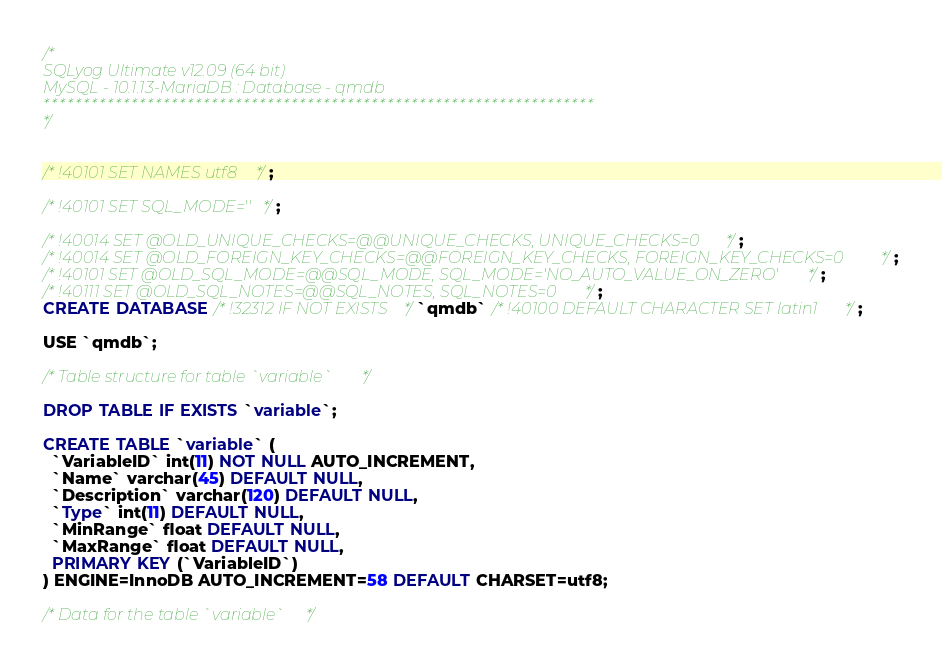Convert code to text. <code><loc_0><loc_0><loc_500><loc_500><_SQL_>/*
SQLyog Ultimate v12.09 (64 bit)
MySQL - 10.1.13-MariaDB : Database - qmdb
*********************************************************************
*/

/*!40101 SET NAMES utf8 */;

/*!40101 SET SQL_MODE=''*/;

/*!40014 SET @OLD_UNIQUE_CHECKS=@@UNIQUE_CHECKS, UNIQUE_CHECKS=0 */;
/*!40014 SET @OLD_FOREIGN_KEY_CHECKS=@@FOREIGN_KEY_CHECKS, FOREIGN_KEY_CHECKS=0 */;
/*!40101 SET @OLD_SQL_MODE=@@SQL_MODE, SQL_MODE='NO_AUTO_VALUE_ON_ZERO' */;
/*!40111 SET @OLD_SQL_NOTES=@@SQL_NOTES, SQL_NOTES=0 */;
CREATE DATABASE /*!32312 IF NOT EXISTS*/`qmdb` /*!40100 DEFAULT CHARACTER SET latin1 */;

USE `qmdb`;

/*Table structure for table `variable` */

DROP TABLE IF EXISTS `variable`;

CREATE TABLE `variable` (
  `VariableID` int(11) NOT NULL AUTO_INCREMENT,
  `Name` varchar(45) DEFAULT NULL,
  `Description` varchar(120) DEFAULT NULL,
  `Type` int(11) DEFAULT NULL,
  `MinRange` float DEFAULT NULL,
  `MaxRange` float DEFAULT NULL,
  PRIMARY KEY (`VariableID`)
) ENGINE=InnoDB AUTO_INCREMENT=58 DEFAULT CHARSET=utf8;

/*Data for the table `variable` */
</code> 